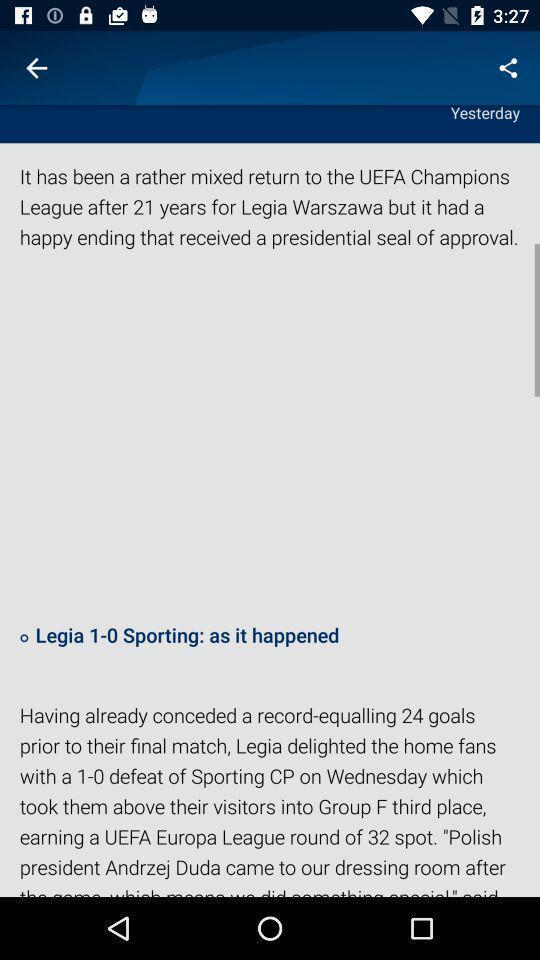Please provide a description for this image. Page with information of. 